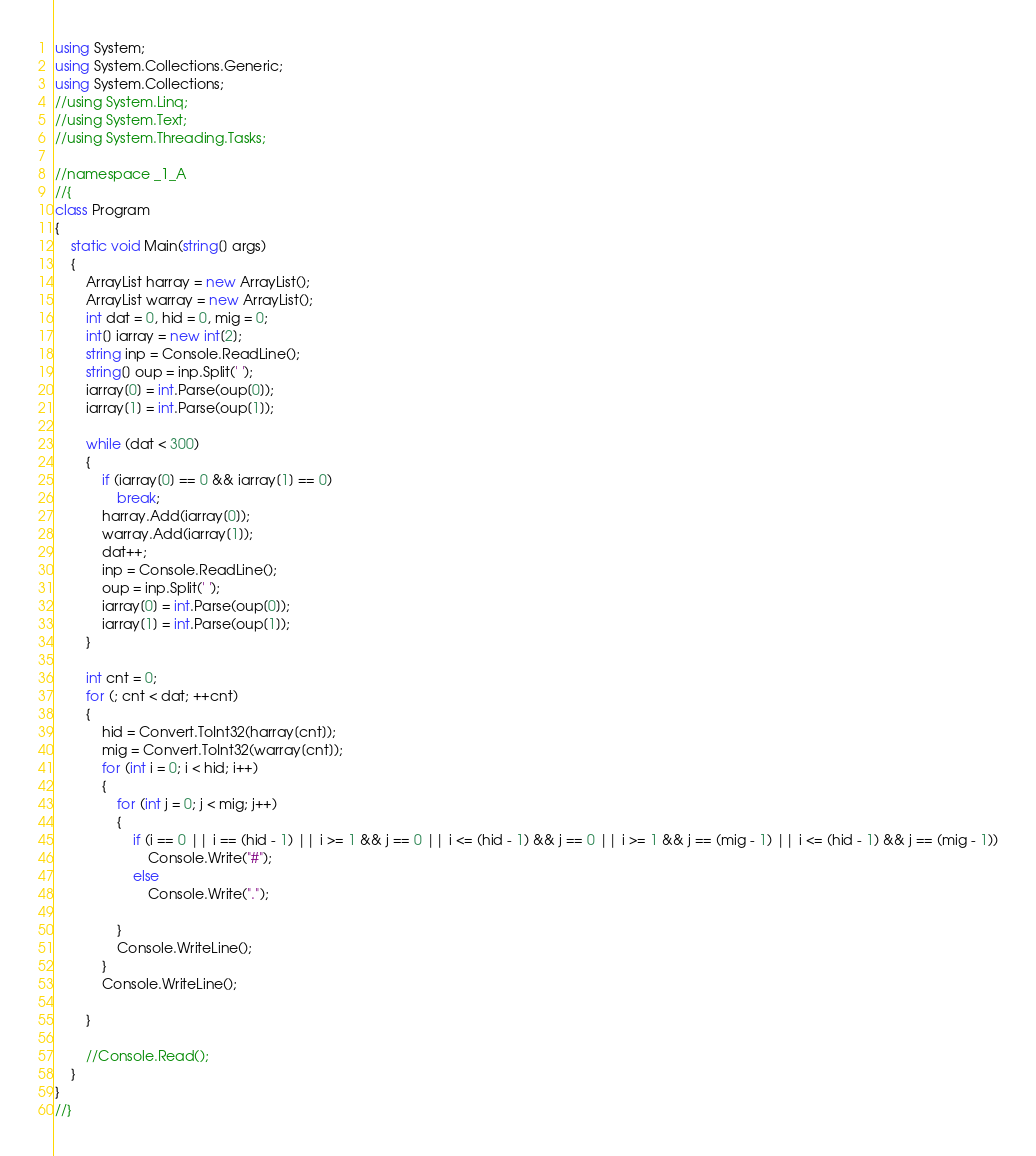Convert code to text. <code><loc_0><loc_0><loc_500><loc_500><_C#_>using System;
using System.Collections.Generic;
using System.Collections;
//using System.Linq;
//using System.Text;
//using System.Threading.Tasks;

//namespace _1_A
//{
class Program
{
    static void Main(string[] args)
    {
        ArrayList harray = new ArrayList();
        ArrayList warray = new ArrayList();
        int dat = 0, hid = 0, mig = 0;
        int[] iarray = new int[2];
        string inp = Console.ReadLine();
        string[] oup = inp.Split(' ');
        iarray[0] = int.Parse(oup[0]);
        iarray[1] = int.Parse(oup[1]);

        while (dat < 300)
        {
            if (iarray[0] == 0 && iarray[1] == 0)
                break;
            harray.Add(iarray[0]);
            warray.Add(iarray[1]);
            dat++;
            inp = Console.ReadLine();
            oup = inp.Split(' ');
            iarray[0] = int.Parse(oup[0]);
            iarray[1] = int.Parse(oup[1]);
        }

        int cnt = 0;
        for (; cnt < dat; ++cnt)
        {
            hid = Convert.ToInt32(harray[cnt]);
            mig = Convert.ToInt32(warray[cnt]);
            for (int i = 0; i < hid; i++)
            {
                for (int j = 0; j < mig; j++)
                {
                    if (i == 0 || i == (hid - 1) || i >= 1 && j == 0 || i <= (hid - 1) && j == 0 || i >= 1 && j == (mig - 1) || i <= (hid - 1) && j == (mig - 1))
                        Console.Write("#");
                    else
                        Console.Write(".");
                        
                }
                Console.WriteLine();
            }
            Console.WriteLine();

        }

        //Console.Read();
    }
}
//}</code> 